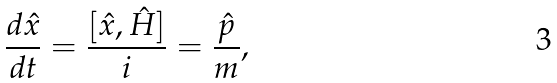Convert formula to latex. <formula><loc_0><loc_0><loc_500><loc_500>\frac { d \hat { x } } { d t } = \frac { [ \hat { x } , \hat { H } ] } { i } = \frac { \hat { p } } { m } ,</formula> 